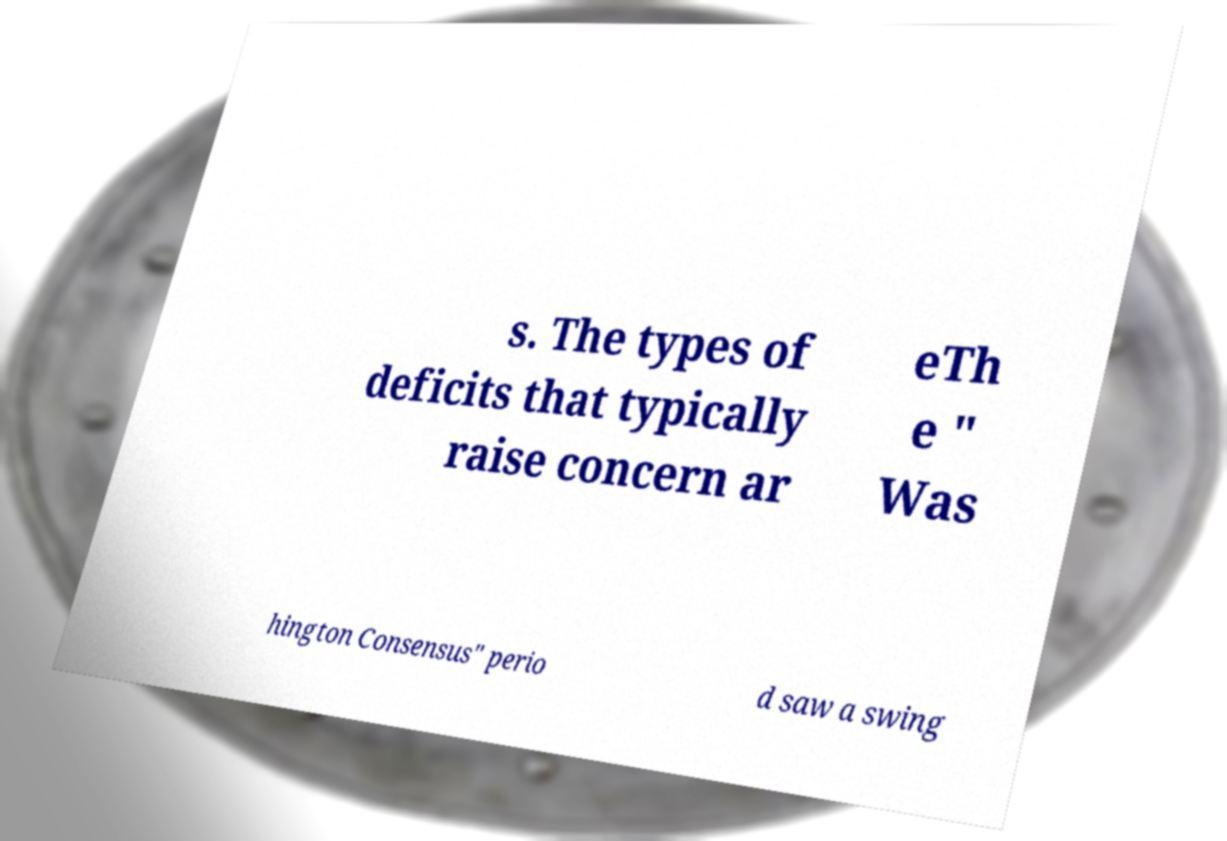Could you extract and type out the text from this image? s. The types of deficits that typically raise concern ar eTh e " Was hington Consensus" perio d saw a swing 